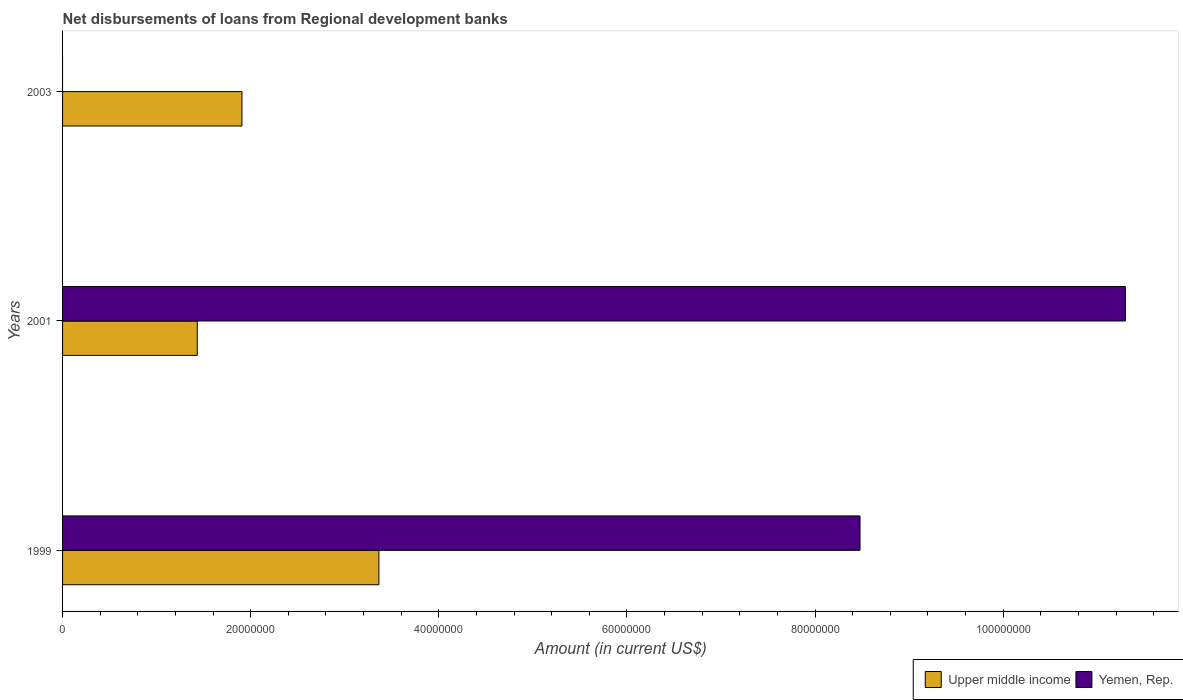How many bars are there on the 1st tick from the top?
Your response must be concise. 1. What is the label of the 3rd group of bars from the top?
Make the answer very short. 1999. In how many cases, is the number of bars for a given year not equal to the number of legend labels?
Make the answer very short. 1. What is the amount of disbursements of loans from regional development banks in Yemen, Rep. in 2003?
Provide a succinct answer. 0. Across all years, what is the maximum amount of disbursements of loans from regional development banks in Upper middle income?
Make the answer very short. 3.36e+07. Across all years, what is the minimum amount of disbursements of loans from regional development banks in Yemen, Rep.?
Ensure brevity in your answer.  0. What is the total amount of disbursements of loans from regional development banks in Upper middle income in the graph?
Provide a short and direct response. 6.70e+07. What is the difference between the amount of disbursements of loans from regional development banks in Upper middle income in 1999 and that in 2003?
Keep it short and to the point. 1.46e+07. What is the difference between the amount of disbursements of loans from regional development banks in Yemen, Rep. in 2001 and the amount of disbursements of loans from regional development banks in Upper middle income in 2003?
Ensure brevity in your answer.  9.39e+07. What is the average amount of disbursements of loans from regional development banks in Yemen, Rep. per year?
Offer a very short reply. 6.59e+07. In the year 1999, what is the difference between the amount of disbursements of loans from regional development banks in Upper middle income and amount of disbursements of loans from regional development banks in Yemen, Rep.?
Offer a very short reply. -5.11e+07. In how many years, is the amount of disbursements of loans from regional development banks in Upper middle income greater than 84000000 US$?
Offer a terse response. 0. What is the ratio of the amount of disbursements of loans from regional development banks in Upper middle income in 1999 to that in 2003?
Your answer should be very brief. 1.76. Is the difference between the amount of disbursements of loans from regional development banks in Upper middle income in 1999 and 2001 greater than the difference between the amount of disbursements of loans from regional development banks in Yemen, Rep. in 1999 and 2001?
Give a very brief answer. Yes. What is the difference between the highest and the second highest amount of disbursements of loans from regional development banks in Upper middle income?
Your response must be concise. 1.46e+07. What is the difference between the highest and the lowest amount of disbursements of loans from regional development banks in Yemen, Rep.?
Ensure brevity in your answer.  1.13e+08. Are all the bars in the graph horizontal?
Make the answer very short. Yes. How many years are there in the graph?
Give a very brief answer. 3. What is the difference between two consecutive major ticks on the X-axis?
Offer a terse response. 2.00e+07. Does the graph contain any zero values?
Your answer should be compact. Yes. Does the graph contain grids?
Keep it short and to the point. No. How are the legend labels stacked?
Provide a short and direct response. Horizontal. What is the title of the graph?
Your answer should be very brief. Net disbursements of loans from Regional development banks. Does "Bermuda" appear as one of the legend labels in the graph?
Keep it short and to the point. No. What is the label or title of the X-axis?
Your answer should be very brief. Amount (in current US$). What is the label or title of the Y-axis?
Provide a succinct answer. Years. What is the Amount (in current US$) of Upper middle income in 1999?
Offer a very short reply. 3.36e+07. What is the Amount (in current US$) in Yemen, Rep. in 1999?
Your answer should be compact. 8.48e+07. What is the Amount (in current US$) in Upper middle income in 2001?
Ensure brevity in your answer.  1.43e+07. What is the Amount (in current US$) in Yemen, Rep. in 2001?
Give a very brief answer. 1.13e+08. What is the Amount (in current US$) in Upper middle income in 2003?
Keep it short and to the point. 1.91e+07. What is the Amount (in current US$) of Yemen, Rep. in 2003?
Give a very brief answer. 0. Across all years, what is the maximum Amount (in current US$) in Upper middle income?
Offer a very short reply. 3.36e+07. Across all years, what is the maximum Amount (in current US$) of Yemen, Rep.?
Offer a terse response. 1.13e+08. Across all years, what is the minimum Amount (in current US$) in Upper middle income?
Give a very brief answer. 1.43e+07. What is the total Amount (in current US$) in Upper middle income in the graph?
Your response must be concise. 6.70e+07. What is the total Amount (in current US$) in Yemen, Rep. in the graph?
Your answer should be compact. 1.98e+08. What is the difference between the Amount (in current US$) in Upper middle income in 1999 and that in 2001?
Ensure brevity in your answer.  1.93e+07. What is the difference between the Amount (in current US$) of Yemen, Rep. in 1999 and that in 2001?
Offer a very short reply. -2.82e+07. What is the difference between the Amount (in current US$) in Upper middle income in 1999 and that in 2003?
Provide a succinct answer. 1.46e+07. What is the difference between the Amount (in current US$) of Upper middle income in 2001 and that in 2003?
Your response must be concise. -4.75e+06. What is the difference between the Amount (in current US$) of Upper middle income in 1999 and the Amount (in current US$) of Yemen, Rep. in 2001?
Your response must be concise. -7.94e+07. What is the average Amount (in current US$) in Upper middle income per year?
Your answer should be compact. 2.23e+07. What is the average Amount (in current US$) in Yemen, Rep. per year?
Give a very brief answer. 6.59e+07. In the year 1999, what is the difference between the Amount (in current US$) in Upper middle income and Amount (in current US$) in Yemen, Rep.?
Your answer should be compact. -5.11e+07. In the year 2001, what is the difference between the Amount (in current US$) of Upper middle income and Amount (in current US$) of Yemen, Rep.?
Provide a short and direct response. -9.87e+07. What is the ratio of the Amount (in current US$) in Upper middle income in 1999 to that in 2001?
Your answer should be very brief. 2.35. What is the ratio of the Amount (in current US$) of Yemen, Rep. in 1999 to that in 2001?
Your answer should be very brief. 0.75. What is the ratio of the Amount (in current US$) of Upper middle income in 1999 to that in 2003?
Your answer should be very brief. 1.76. What is the ratio of the Amount (in current US$) in Upper middle income in 2001 to that in 2003?
Give a very brief answer. 0.75. What is the difference between the highest and the second highest Amount (in current US$) in Upper middle income?
Your answer should be very brief. 1.46e+07. What is the difference between the highest and the lowest Amount (in current US$) in Upper middle income?
Provide a succinct answer. 1.93e+07. What is the difference between the highest and the lowest Amount (in current US$) in Yemen, Rep.?
Provide a short and direct response. 1.13e+08. 